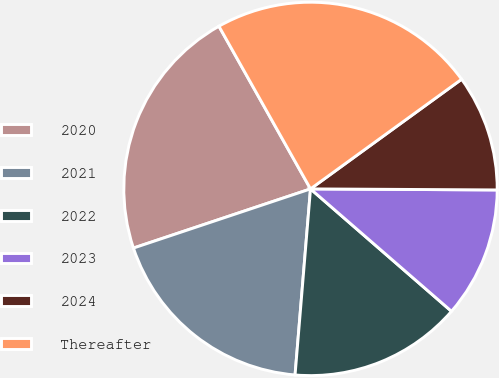Convert chart. <chart><loc_0><loc_0><loc_500><loc_500><pie_chart><fcel>2020<fcel>2021<fcel>2022<fcel>2023<fcel>2024<fcel>Thereafter<nl><fcel>21.97%<fcel>18.55%<fcel>14.94%<fcel>11.29%<fcel>10.08%<fcel>23.17%<nl></chart> 